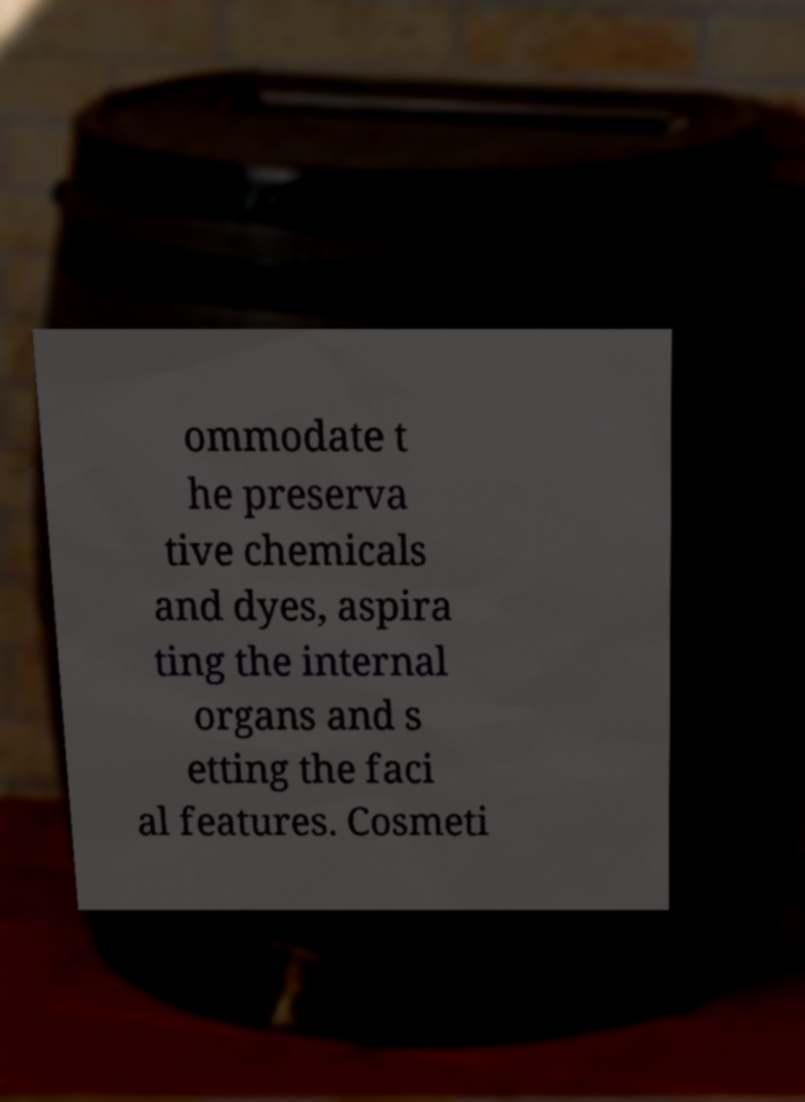Could you assist in decoding the text presented in this image and type it out clearly? ommodate t he preserva tive chemicals and dyes, aspira ting the internal organs and s etting the faci al features. Cosmeti 